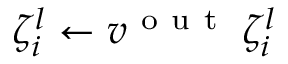Convert formula to latex. <formula><loc_0><loc_0><loc_500><loc_500>\zeta _ { i } ^ { l } \gets v ^ { o u t } \, \zeta _ { i } ^ { l }</formula> 